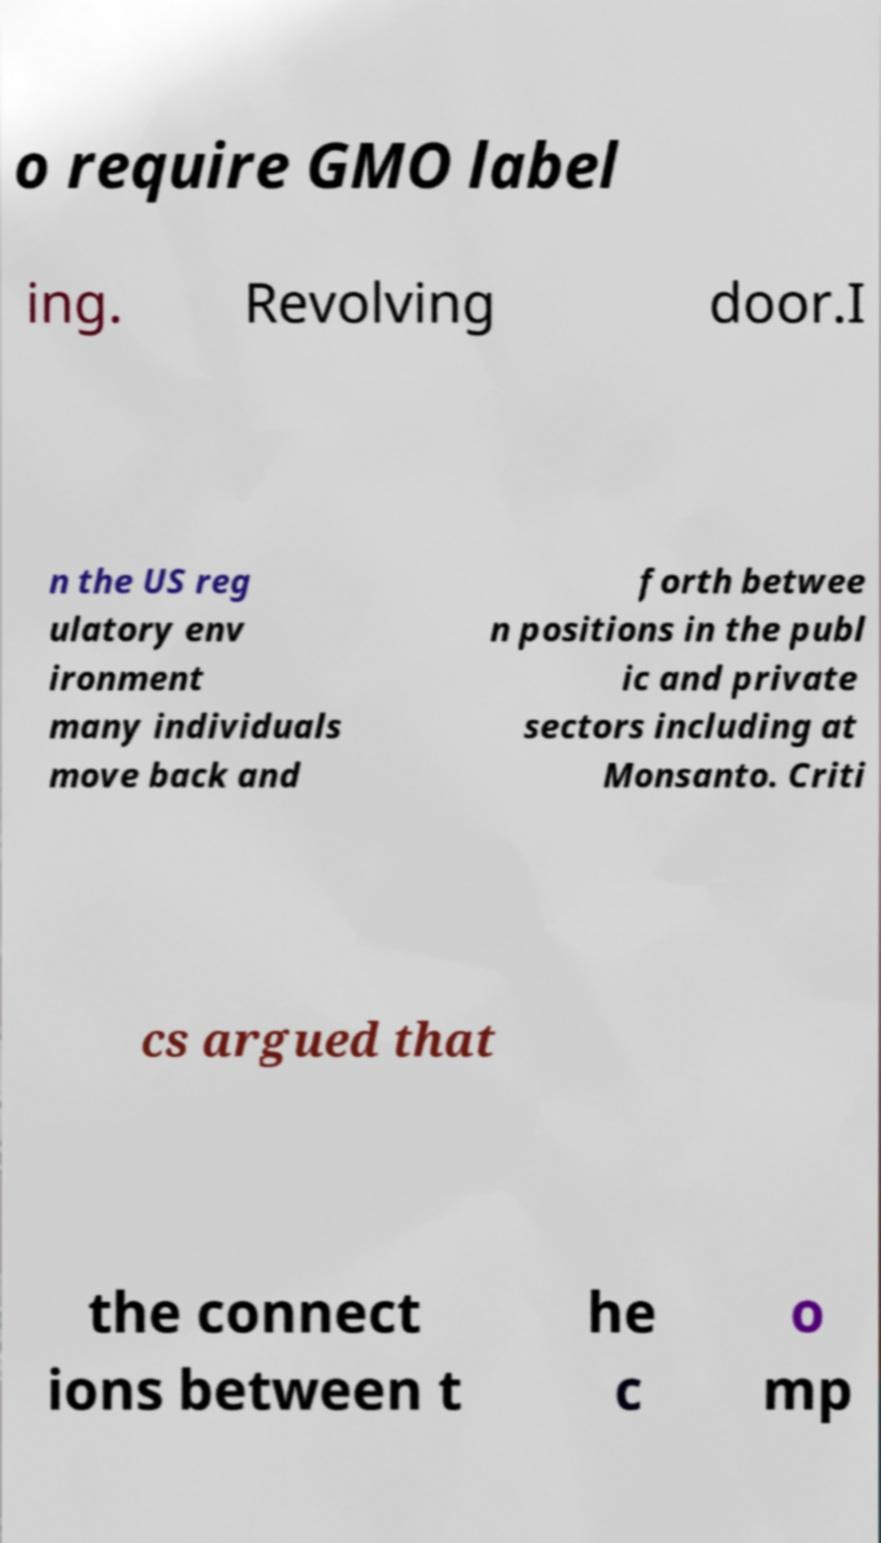Could you extract and type out the text from this image? o require GMO label ing. Revolving door.I n the US reg ulatory env ironment many individuals move back and forth betwee n positions in the publ ic and private sectors including at Monsanto. Criti cs argued that the connect ions between t he c o mp 